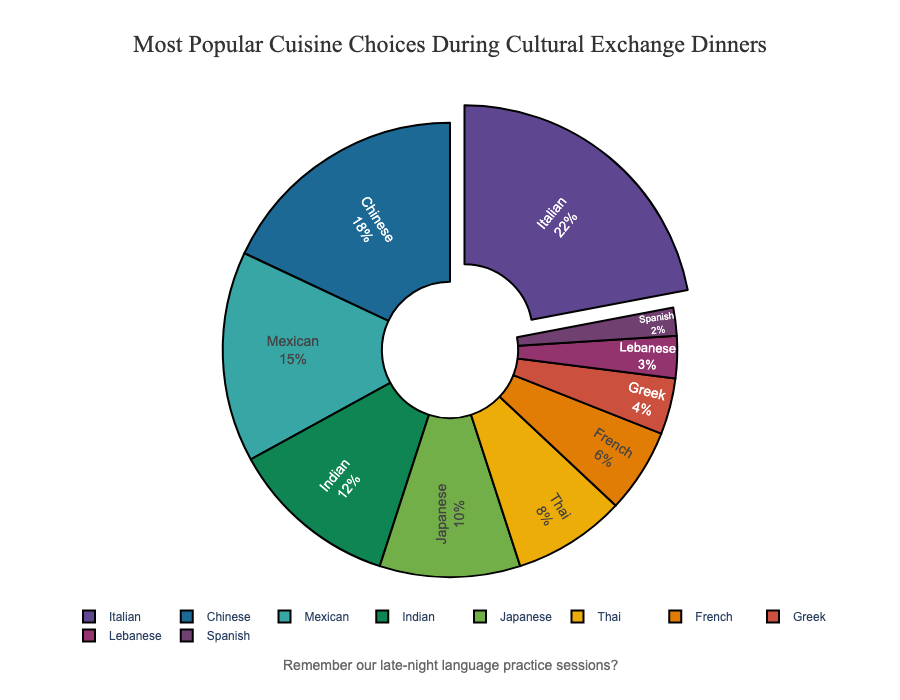Which cuisine is the most popular during cultural exchange dinners? The pie chart shows the percentage distribution of cuisines, where the largest segment is marked with a slight separation from the rest. By identifying the largest segment, we see that Italian cuisine is the most popular.
Answer: Italian Which two cuisines are equally less popular, each comprising less than 5% of the choices? By examining the smaller slices of the pie chart, we identify the ones under 5%. Greek and Lebanese cuisines each constitute 4% and 3% respectively.
Answer: Greek, Lebanese What is the combined percentage of Mexican and Indian cuisines? To find the combined percentage, add the percentages of Mexican and Indian cuisines: 15% (Mexican) + 12% (Indian) = 27%.
Answer: 27% Which cuisine is more popular, Japanese or Thai? The pie chart shows the percentages for Japanese and Thai cuisines: Japanese (10%) and Thai (8%). Comparing these two values, Japanese cuisine is more popular.
Answer: Japanese How much more popular is Chinese cuisine compared to French cuisine? Identify the percentages for Chinese and French cuisines: Chinese (18%) and French (6%). Subtract the percentage of French from Chinese: 18% - 6% = 12%.
Answer: 12% What fraction of the cuisine choices comes from Asian countries? Sum the percentages of Asian cuisines (Chinese, Indian, Japanese, Thai): 18% (Chinese) + 12% (Indian) + 10% (Japanese) + 8% (Thai) = 48%. So, 48% of the choices are from Asian countries.
Answer: 48% Which cuisine has the smallest representation in the pie chart? The smallest segment is the one with the lowest percentage. By examining the chart, Spanish cuisine has the smallest representation with 2%.
Answer: Spanish Between Mexican and Japanese cuisines, which has a higher percentage? The pie chart shows the percentages for Mexican (15%) and Japanese (10%) cuisines. Mexican cuisine has a higher percentage.
Answer: Mexican Which three cuisines together make up more than half of the total cuisine choices? Identify the top percentages and sum them: Italian (22%) + Chinese (18%) + Mexican (15%) = 55%, which is more than half of the total 100%.
Answer: Italian, Chinese, Mexican 